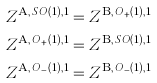<formula> <loc_0><loc_0><loc_500><loc_500>Z ^ { \text {A} , \, S O ( 1 ) , 1 } & = Z ^ { \text {B} , \, O _ { + } ( 1 ) , 1 } \\ Z ^ { \text {A} , \, O _ { + } ( 1 ) , 1 } & = Z ^ { \text {B} , \, S O ( 1 ) , 1 } \\ Z ^ { \text {A} , \, O _ { - } ( 1 ) , 1 } & = Z ^ { \text {B} , \, O _ { - } ( 1 ) , 1 }</formula> 